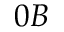Convert formula to latex. <formula><loc_0><loc_0><loc_500><loc_500>0 B</formula> 